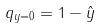Convert formula to latex. <formula><loc_0><loc_0><loc_500><loc_500>q _ { y = 0 } = 1 - \hat { y }</formula> 